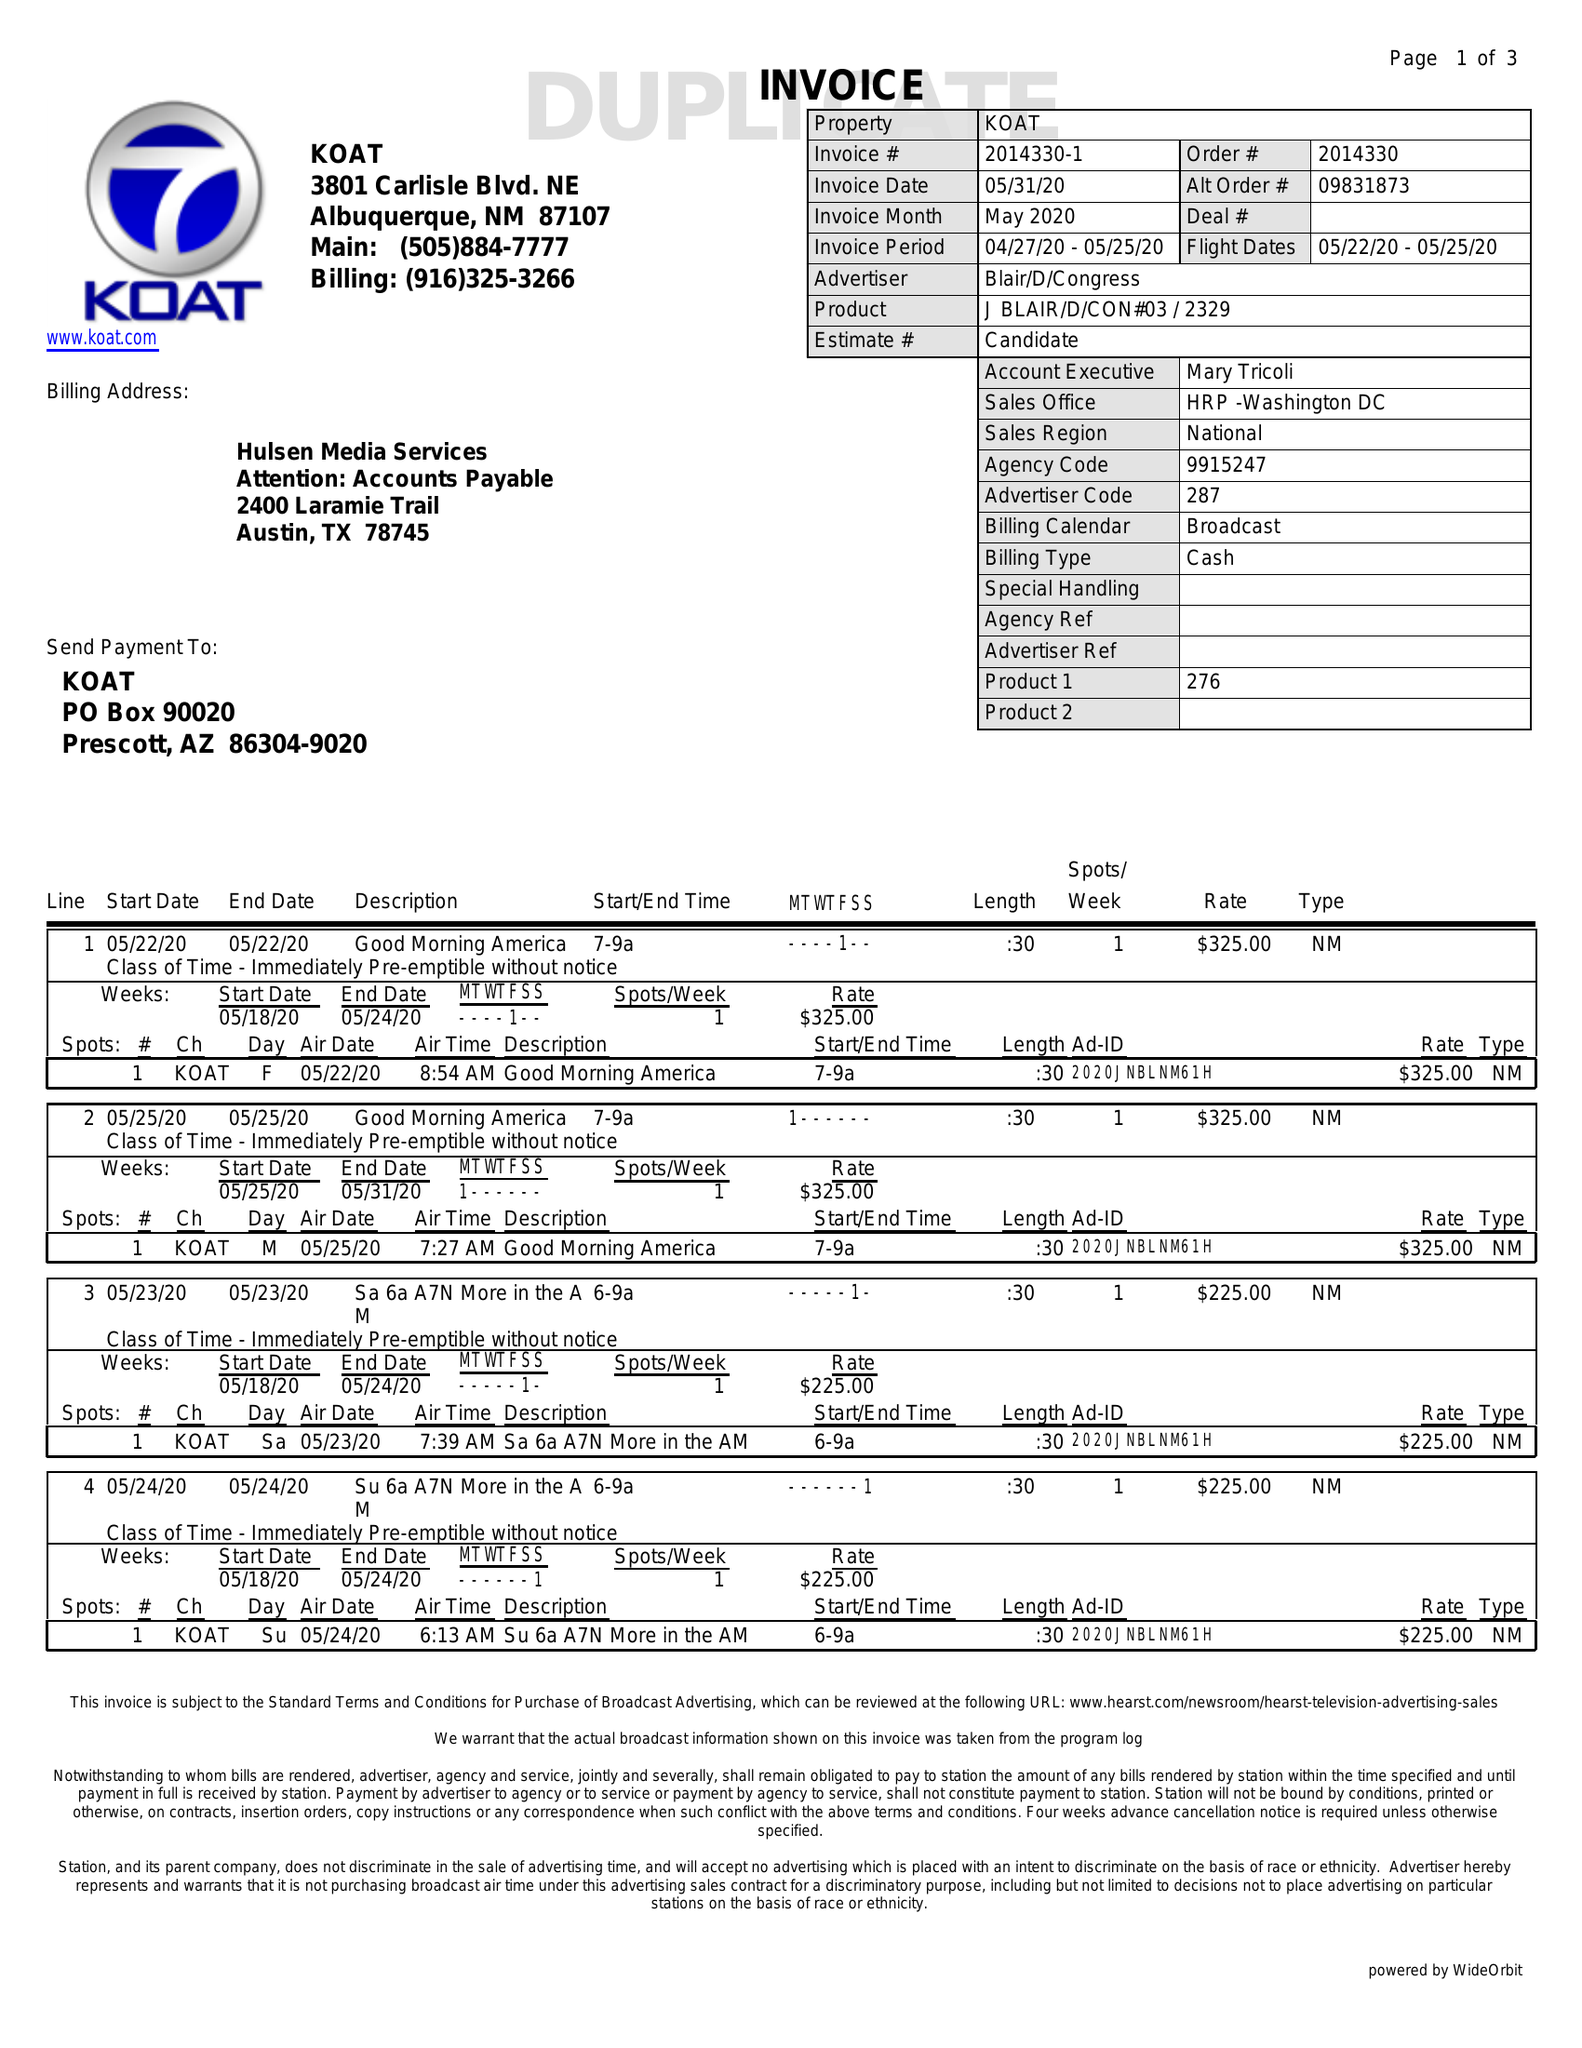What is the value for the gross_amount?
Answer the question using a single word or phrase. 3425.00 